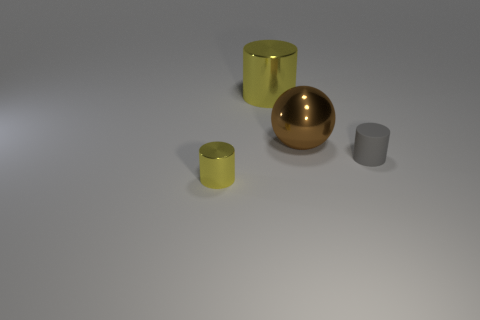What materials do these objects appear to be made of? The objects in the image seem to have different materials. The small yellow cylinder and the large golden sphere might be made of a polished metal due to their reflective surface. The gray cylinder and small gray cube might be made of a matte material, possibly ceramic or plastic, as they do not reflect light in the same way. 